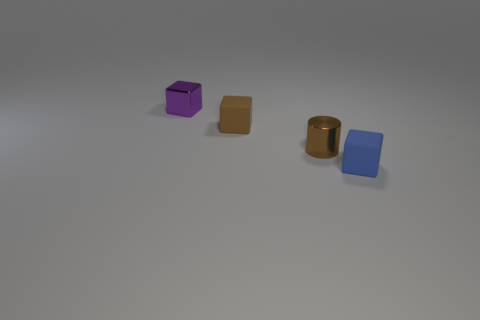Is the number of small cylinders that are in front of the brown cylinder less than the number of purple metallic cubes?
Ensure brevity in your answer.  Yes. The purple thing that is the same size as the brown matte block is what shape?
Your response must be concise. Cube. How many other things are there of the same color as the metallic block?
Make the answer very short. 0. What number of things are either small cylinders or rubber cubes to the left of the tiny blue object?
Your answer should be very brief. 2. Is the number of small brown things that are behind the brown rubber thing less than the number of small brown rubber things that are left of the metal cube?
Offer a terse response. No. What number of other things are there of the same material as the blue object
Keep it short and to the point. 1. There is a rubber object behind the small blue rubber cube; is its color the same as the cylinder?
Your answer should be compact. Yes. There is a matte thing that is left of the brown metal cylinder; is there a rubber thing to the right of it?
Offer a very short reply. Yes. What is the object that is both on the left side of the blue rubber block and on the right side of the brown rubber thing made of?
Make the answer very short. Metal. There is a small purple object that is the same material as the small brown cylinder; what shape is it?
Your response must be concise. Cube. 